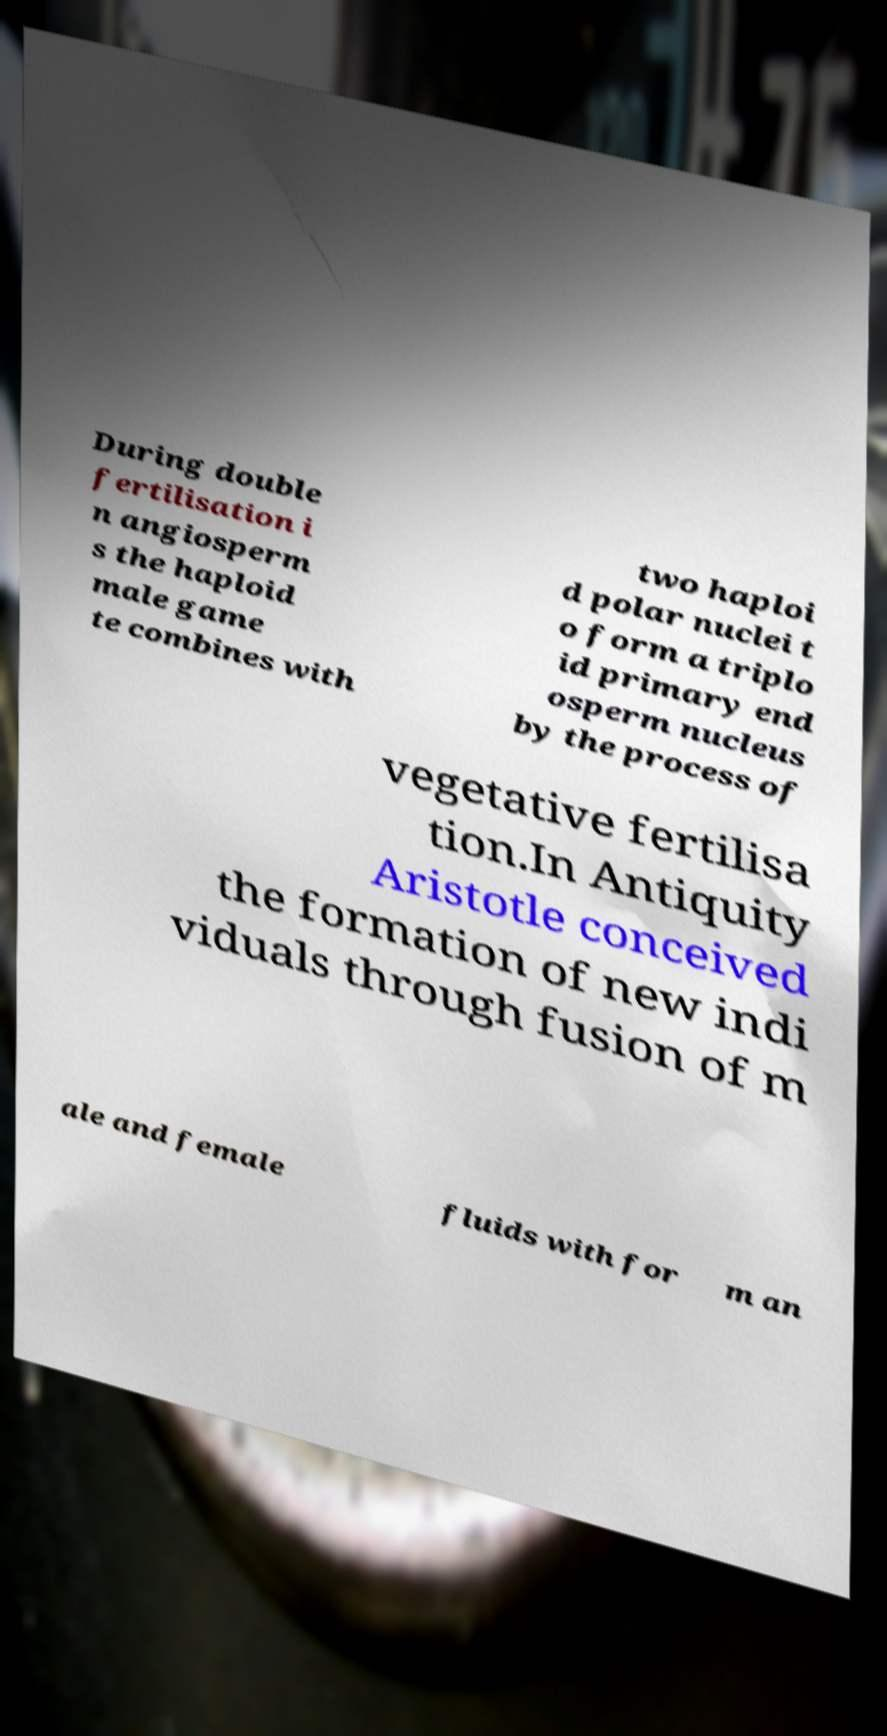There's text embedded in this image that I need extracted. Can you transcribe it verbatim? During double fertilisation i n angiosperm s the haploid male game te combines with two haploi d polar nuclei t o form a triplo id primary end osperm nucleus by the process of vegetative fertilisa tion.In Antiquity Aristotle conceived the formation of new indi viduals through fusion of m ale and female fluids with for m an 